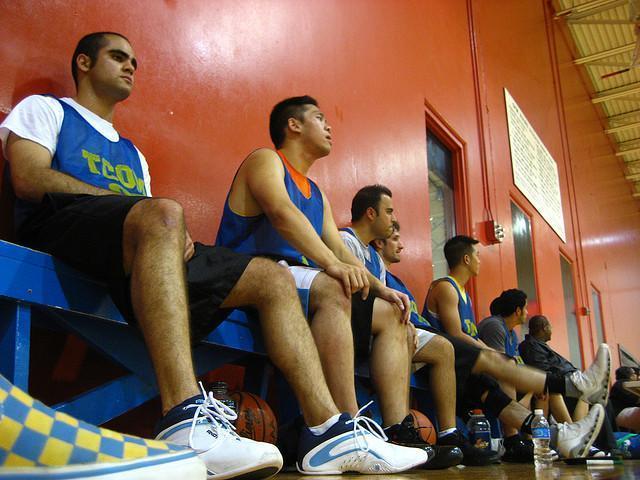How many people are there?
Give a very brief answer. 8. How many benches are visible?
Give a very brief answer. 1. 